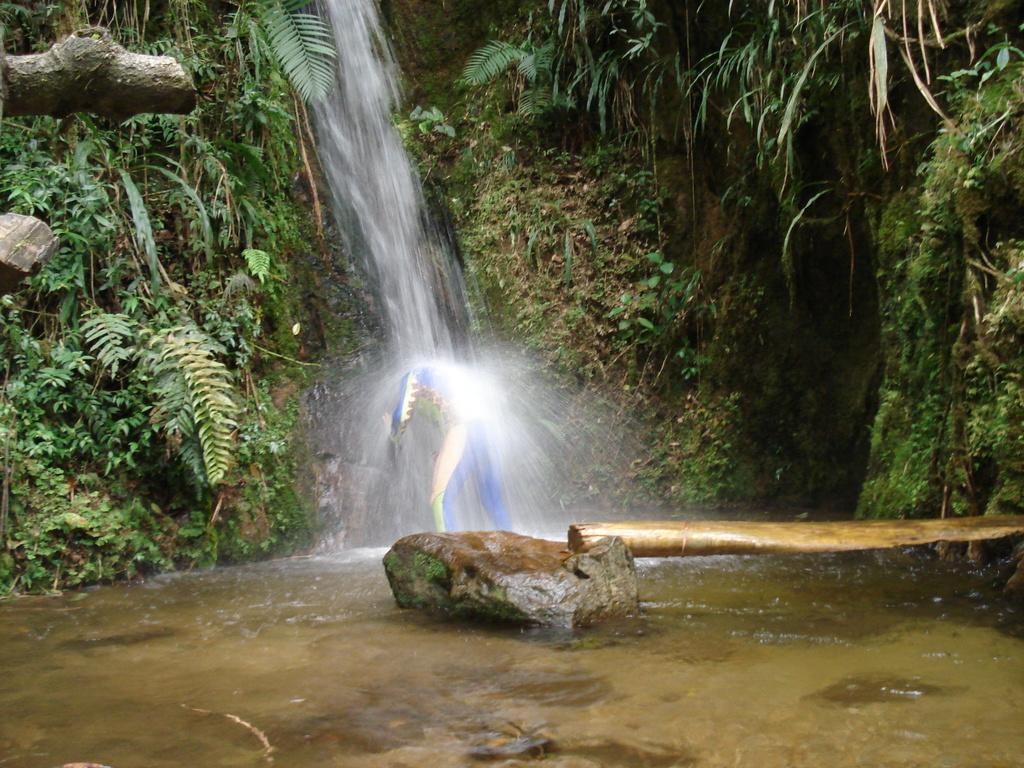Who or what is present in the image? There is a person in the image. What is the person wearing? The person is wearing clothes. What natural feature can be seen in the image? There is a waterfall in the image. What object is visible in the image? There is a wooden stick in the image. What type of liquid is present in the image? There is water visible in the image. What type of terrain is present in the image? There are stones in the image. What type of vegetation is present in the image? There are plants and grass in the image. Can you see the moon in the image? No, the moon is not present in the image. Is the person swimming in the waterfall in the image? There is no indication that the person is swimming in the waterfall in the image. 